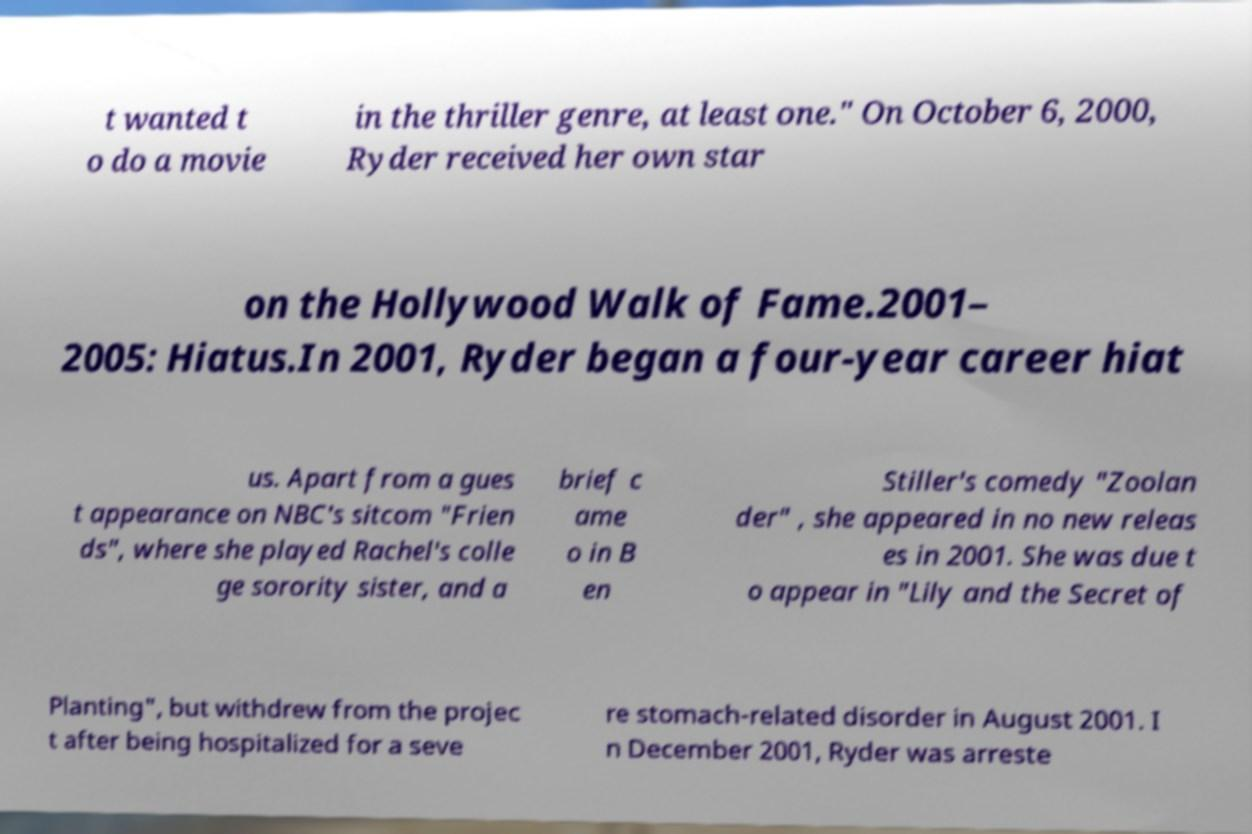Can you accurately transcribe the text from the provided image for me? t wanted t o do a movie in the thriller genre, at least one." On October 6, 2000, Ryder received her own star on the Hollywood Walk of Fame.2001– 2005: Hiatus.In 2001, Ryder began a four-year career hiat us. Apart from a gues t appearance on NBC's sitcom "Frien ds", where she played Rachel's colle ge sorority sister, and a brief c ame o in B en Stiller's comedy "Zoolan der" , she appeared in no new releas es in 2001. She was due t o appear in "Lily and the Secret of Planting", but withdrew from the projec t after being hospitalized for a seve re stomach-related disorder in August 2001. I n December 2001, Ryder was arreste 